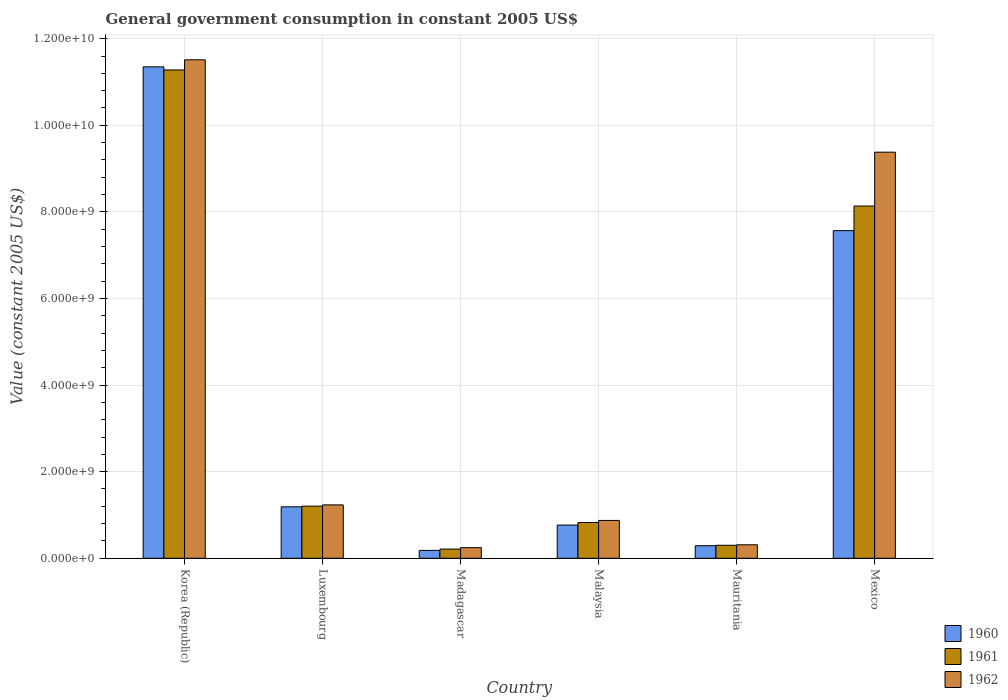How many groups of bars are there?
Your response must be concise. 6. How many bars are there on the 4th tick from the right?
Your response must be concise. 3. In how many cases, is the number of bars for a given country not equal to the number of legend labels?
Ensure brevity in your answer.  0. What is the government conusmption in 1962 in Malaysia?
Offer a terse response. 8.74e+08. Across all countries, what is the maximum government conusmption in 1961?
Give a very brief answer. 1.13e+1. Across all countries, what is the minimum government conusmption in 1961?
Provide a short and direct response. 2.12e+08. In which country was the government conusmption in 1961 maximum?
Your answer should be very brief. Korea (Republic). In which country was the government conusmption in 1962 minimum?
Your response must be concise. Madagascar. What is the total government conusmption in 1961 in the graph?
Make the answer very short. 2.20e+1. What is the difference between the government conusmption in 1961 in Malaysia and that in Mauritania?
Your answer should be compact. 5.26e+08. What is the difference between the government conusmption in 1960 in Mexico and the government conusmption in 1962 in Korea (Republic)?
Provide a succinct answer. -3.95e+09. What is the average government conusmption in 1961 per country?
Make the answer very short. 3.66e+09. What is the difference between the government conusmption of/in 1962 and government conusmption of/in 1960 in Mexico?
Give a very brief answer. 1.81e+09. What is the ratio of the government conusmption in 1960 in Korea (Republic) to that in Mauritania?
Your response must be concise. 39.21. Is the difference between the government conusmption in 1962 in Luxembourg and Mexico greater than the difference between the government conusmption in 1960 in Luxembourg and Mexico?
Offer a very short reply. No. What is the difference between the highest and the second highest government conusmption in 1961?
Offer a very short reply. -6.93e+09. What is the difference between the highest and the lowest government conusmption in 1960?
Your answer should be compact. 1.12e+1. Is the sum of the government conusmption in 1961 in Korea (Republic) and Luxembourg greater than the maximum government conusmption in 1962 across all countries?
Keep it short and to the point. Yes. Is it the case that in every country, the sum of the government conusmption in 1962 and government conusmption in 1961 is greater than the government conusmption in 1960?
Give a very brief answer. Yes. Are all the bars in the graph horizontal?
Offer a terse response. No. Are the values on the major ticks of Y-axis written in scientific E-notation?
Ensure brevity in your answer.  Yes. Does the graph contain any zero values?
Offer a terse response. No. Does the graph contain grids?
Keep it short and to the point. Yes. Where does the legend appear in the graph?
Make the answer very short. Bottom right. How many legend labels are there?
Ensure brevity in your answer.  3. How are the legend labels stacked?
Your answer should be compact. Vertical. What is the title of the graph?
Offer a terse response. General government consumption in constant 2005 US$. Does "2007" appear as one of the legend labels in the graph?
Your answer should be compact. No. What is the label or title of the X-axis?
Provide a succinct answer. Country. What is the label or title of the Y-axis?
Make the answer very short. Value (constant 2005 US$). What is the Value (constant 2005 US$) of 1960 in Korea (Republic)?
Offer a terse response. 1.13e+1. What is the Value (constant 2005 US$) of 1961 in Korea (Republic)?
Make the answer very short. 1.13e+1. What is the Value (constant 2005 US$) in 1962 in Korea (Republic)?
Your answer should be very brief. 1.15e+1. What is the Value (constant 2005 US$) in 1960 in Luxembourg?
Keep it short and to the point. 1.19e+09. What is the Value (constant 2005 US$) in 1961 in Luxembourg?
Provide a succinct answer. 1.20e+09. What is the Value (constant 2005 US$) in 1962 in Luxembourg?
Your response must be concise. 1.23e+09. What is the Value (constant 2005 US$) of 1960 in Madagascar?
Make the answer very short. 1.82e+08. What is the Value (constant 2005 US$) of 1961 in Madagascar?
Offer a terse response. 2.12e+08. What is the Value (constant 2005 US$) of 1962 in Madagascar?
Offer a terse response. 2.45e+08. What is the Value (constant 2005 US$) in 1960 in Malaysia?
Your answer should be compact. 7.67e+08. What is the Value (constant 2005 US$) of 1961 in Malaysia?
Provide a short and direct response. 8.26e+08. What is the Value (constant 2005 US$) in 1962 in Malaysia?
Your answer should be compact. 8.74e+08. What is the Value (constant 2005 US$) in 1960 in Mauritania?
Provide a succinct answer. 2.89e+08. What is the Value (constant 2005 US$) of 1961 in Mauritania?
Your answer should be very brief. 3.00e+08. What is the Value (constant 2005 US$) of 1962 in Mauritania?
Ensure brevity in your answer.  3.11e+08. What is the Value (constant 2005 US$) of 1960 in Mexico?
Make the answer very short. 7.57e+09. What is the Value (constant 2005 US$) of 1961 in Mexico?
Offer a very short reply. 8.13e+09. What is the Value (constant 2005 US$) of 1962 in Mexico?
Your response must be concise. 9.38e+09. Across all countries, what is the maximum Value (constant 2005 US$) of 1960?
Provide a succinct answer. 1.13e+1. Across all countries, what is the maximum Value (constant 2005 US$) in 1961?
Provide a succinct answer. 1.13e+1. Across all countries, what is the maximum Value (constant 2005 US$) of 1962?
Offer a very short reply. 1.15e+1. Across all countries, what is the minimum Value (constant 2005 US$) in 1960?
Offer a very short reply. 1.82e+08. Across all countries, what is the minimum Value (constant 2005 US$) in 1961?
Make the answer very short. 2.12e+08. Across all countries, what is the minimum Value (constant 2005 US$) in 1962?
Your answer should be very brief. 2.45e+08. What is the total Value (constant 2005 US$) in 1960 in the graph?
Your answer should be compact. 2.13e+1. What is the total Value (constant 2005 US$) of 1961 in the graph?
Provide a short and direct response. 2.20e+1. What is the total Value (constant 2005 US$) of 1962 in the graph?
Provide a short and direct response. 2.36e+1. What is the difference between the Value (constant 2005 US$) of 1960 in Korea (Republic) and that in Luxembourg?
Keep it short and to the point. 1.02e+1. What is the difference between the Value (constant 2005 US$) in 1961 in Korea (Republic) and that in Luxembourg?
Keep it short and to the point. 1.01e+1. What is the difference between the Value (constant 2005 US$) in 1962 in Korea (Republic) and that in Luxembourg?
Provide a short and direct response. 1.03e+1. What is the difference between the Value (constant 2005 US$) in 1960 in Korea (Republic) and that in Madagascar?
Keep it short and to the point. 1.12e+1. What is the difference between the Value (constant 2005 US$) in 1961 in Korea (Republic) and that in Madagascar?
Give a very brief answer. 1.11e+1. What is the difference between the Value (constant 2005 US$) of 1962 in Korea (Republic) and that in Madagascar?
Your answer should be compact. 1.13e+1. What is the difference between the Value (constant 2005 US$) of 1960 in Korea (Republic) and that in Malaysia?
Your answer should be compact. 1.06e+1. What is the difference between the Value (constant 2005 US$) of 1961 in Korea (Republic) and that in Malaysia?
Give a very brief answer. 1.05e+1. What is the difference between the Value (constant 2005 US$) of 1962 in Korea (Republic) and that in Malaysia?
Your response must be concise. 1.06e+1. What is the difference between the Value (constant 2005 US$) in 1960 in Korea (Republic) and that in Mauritania?
Offer a very short reply. 1.11e+1. What is the difference between the Value (constant 2005 US$) in 1961 in Korea (Republic) and that in Mauritania?
Make the answer very short. 1.10e+1. What is the difference between the Value (constant 2005 US$) of 1962 in Korea (Republic) and that in Mauritania?
Keep it short and to the point. 1.12e+1. What is the difference between the Value (constant 2005 US$) of 1960 in Korea (Republic) and that in Mexico?
Offer a very short reply. 3.78e+09. What is the difference between the Value (constant 2005 US$) of 1961 in Korea (Republic) and that in Mexico?
Give a very brief answer. 3.14e+09. What is the difference between the Value (constant 2005 US$) in 1962 in Korea (Republic) and that in Mexico?
Your answer should be compact. 2.13e+09. What is the difference between the Value (constant 2005 US$) in 1960 in Luxembourg and that in Madagascar?
Keep it short and to the point. 1.01e+09. What is the difference between the Value (constant 2005 US$) of 1961 in Luxembourg and that in Madagascar?
Give a very brief answer. 9.92e+08. What is the difference between the Value (constant 2005 US$) in 1962 in Luxembourg and that in Madagascar?
Offer a terse response. 9.87e+08. What is the difference between the Value (constant 2005 US$) in 1960 in Luxembourg and that in Malaysia?
Your response must be concise. 4.21e+08. What is the difference between the Value (constant 2005 US$) of 1961 in Luxembourg and that in Malaysia?
Provide a succinct answer. 3.77e+08. What is the difference between the Value (constant 2005 US$) of 1962 in Luxembourg and that in Malaysia?
Give a very brief answer. 3.59e+08. What is the difference between the Value (constant 2005 US$) of 1960 in Luxembourg and that in Mauritania?
Give a very brief answer. 8.99e+08. What is the difference between the Value (constant 2005 US$) of 1961 in Luxembourg and that in Mauritania?
Make the answer very short. 9.03e+08. What is the difference between the Value (constant 2005 US$) in 1962 in Luxembourg and that in Mauritania?
Make the answer very short. 9.21e+08. What is the difference between the Value (constant 2005 US$) of 1960 in Luxembourg and that in Mexico?
Your answer should be very brief. -6.38e+09. What is the difference between the Value (constant 2005 US$) of 1961 in Luxembourg and that in Mexico?
Your response must be concise. -6.93e+09. What is the difference between the Value (constant 2005 US$) of 1962 in Luxembourg and that in Mexico?
Your response must be concise. -8.15e+09. What is the difference between the Value (constant 2005 US$) of 1960 in Madagascar and that in Malaysia?
Your response must be concise. -5.85e+08. What is the difference between the Value (constant 2005 US$) in 1961 in Madagascar and that in Malaysia?
Your answer should be very brief. -6.14e+08. What is the difference between the Value (constant 2005 US$) of 1962 in Madagascar and that in Malaysia?
Make the answer very short. -6.29e+08. What is the difference between the Value (constant 2005 US$) in 1960 in Madagascar and that in Mauritania?
Your answer should be very brief. -1.08e+08. What is the difference between the Value (constant 2005 US$) of 1961 in Madagascar and that in Mauritania?
Your answer should be very brief. -8.84e+07. What is the difference between the Value (constant 2005 US$) in 1962 in Madagascar and that in Mauritania?
Provide a succinct answer. -6.62e+07. What is the difference between the Value (constant 2005 US$) in 1960 in Madagascar and that in Mexico?
Your answer should be very brief. -7.38e+09. What is the difference between the Value (constant 2005 US$) in 1961 in Madagascar and that in Mexico?
Offer a terse response. -7.92e+09. What is the difference between the Value (constant 2005 US$) in 1962 in Madagascar and that in Mexico?
Ensure brevity in your answer.  -9.13e+09. What is the difference between the Value (constant 2005 US$) of 1960 in Malaysia and that in Mauritania?
Provide a short and direct response. 4.78e+08. What is the difference between the Value (constant 2005 US$) in 1961 in Malaysia and that in Mauritania?
Provide a succinct answer. 5.26e+08. What is the difference between the Value (constant 2005 US$) in 1962 in Malaysia and that in Mauritania?
Offer a terse response. 5.63e+08. What is the difference between the Value (constant 2005 US$) of 1960 in Malaysia and that in Mexico?
Offer a very short reply. -6.80e+09. What is the difference between the Value (constant 2005 US$) of 1961 in Malaysia and that in Mexico?
Your answer should be very brief. -7.31e+09. What is the difference between the Value (constant 2005 US$) in 1962 in Malaysia and that in Mexico?
Offer a terse response. -8.50e+09. What is the difference between the Value (constant 2005 US$) in 1960 in Mauritania and that in Mexico?
Your answer should be compact. -7.28e+09. What is the difference between the Value (constant 2005 US$) in 1961 in Mauritania and that in Mexico?
Your answer should be compact. -7.83e+09. What is the difference between the Value (constant 2005 US$) in 1962 in Mauritania and that in Mexico?
Ensure brevity in your answer.  -9.07e+09. What is the difference between the Value (constant 2005 US$) of 1960 in Korea (Republic) and the Value (constant 2005 US$) of 1961 in Luxembourg?
Ensure brevity in your answer.  1.01e+1. What is the difference between the Value (constant 2005 US$) of 1960 in Korea (Republic) and the Value (constant 2005 US$) of 1962 in Luxembourg?
Your response must be concise. 1.01e+1. What is the difference between the Value (constant 2005 US$) of 1961 in Korea (Republic) and the Value (constant 2005 US$) of 1962 in Luxembourg?
Offer a very short reply. 1.00e+1. What is the difference between the Value (constant 2005 US$) in 1960 in Korea (Republic) and the Value (constant 2005 US$) in 1961 in Madagascar?
Offer a terse response. 1.11e+1. What is the difference between the Value (constant 2005 US$) in 1960 in Korea (Republic) and the Value (constant 2005 US$) in 1962 in Madagascar?
Provide a succinct answer. 1.11e+1. What is the difference between the Value (constant 2005 US$) of 1961 in Korea (Republic) and the Value (constant 2005 US$) of 1962 in Madagascar?
Provide a short and direct response. 1.10e+1. What is the difference between the Value (constant 2005 US$) in 1960 in Korea (Republic) and the Value (constant 2005 US$) in 1961 in Malaysia?
Give a very brief answer. 1.05e+1. What is the difference between the Value (constant 2005 US$) of 1960 in Korea (Republic) and the Value (constant 2005 US$) of 1962 in Malaysia?
Make the answer very short. 1.05e+1. What is the difference between the Value (constant 2005 US$) of 1961 in Korea (Republic) and the Value (constant 2005 US$) of 1962 in Malaysia?
Your response must be concise. 1.04e+1. What is the difference between the Value (constant 2005 US$) in 1960 in Korea (Republic) and the Value (constant 2005 US$) in 1961 in Mauritania?
Offer a terse response. 1.10e+1. What is the difference between the Value (constant 2005 US$) of 1960 in Korea (Republic) and the Value (constant 2005 US$) of 1962 in Mauritania?
Make the answer very short. 1.10e+1. What is the difference between the Value (constant 2005 US$) of 1961 in Korea (Republic) and the Value (constant 2005 US$) of 1962 in Mauritania?
Provide a succinct answer. 1.10e+1. What is the difference between the Value (constant 2005 US$) in 1960 in Korea (Republic) and the Value (constant 2005 US$) in 1961 in Mexico?
Provide a short and direct response. 3.21e+09. What is the difference between the Value (constant 2005 US$) in 1960 in Korea (Republic) and the Value (constant 2005 US$) in 1962 in Mexico?
Offer a very short reply. 1.97e+09. What is the difference between the Value (constant 2005 US$) of 1961 in Korea (Republic) and the Value (constant 2005 US$) of 1962 in Mexico?
Your answer should be very brief. 1.90e+09. What is the difference between the Value (constant 2005 US$) of 1960 in Luxembourg and the Value (constant 2005 US$) of 1961 in Madagascar?
Ensure brevity in your answer.  9.76e+08. What is the difference between the Value (constant 2005 US$) of 1960 in Luxembourg and the Value (constant 2005 US$) of 1962 in Madagascar?
Your response must be concise. 9.43e+08. What is the difference between the Value (constant 2005 US$) of 1961 in Luxembourg and the Value (constant 2005 US$) of 1962 in Madagascar?
Provide a succinct answer. 9.59e+08. What is the difference between the Value (constant 2005 US$) of 1960 in Luxembourg and the Value (constant 2005 US$) of 1961 in Malaysia?
Provide a succinct answer. 3.62e+08. What is the difference between the Value (constant 2005 US$) of 1960 in Luxembourg and the Value (constant 2005 US$) of 1962 in Malaysia?
Your answer should be compact. 3.14e+08. What is the difference between the Value (constant 2005 US$) in 1961 in Luxembourg and the Value (constant 2005 US$) in 1962 in Malaysia?
Your answer should be compact. 3.30e+08. What is the difference between the Value (constant 2005 US$) of 1960 in Luxembourg and the Value (constant 2005 US$) of 1961 in Mauritania?
Offer a terse response. 8.88e+08. What is the difference between the Value (constant 2005 US$) in 1960 in Luxembourg and the Value (constant 2005 US$) in 1962 in Mauritania?
Your answer should be compact. 8.77e+08. What is the difference between the Value (constant 2005 US$) in 1961 in Luxembourg and the Value (constant 2005 US$) in 1962 in Mauritania?
Offer a terse response. 8.92e+08. What is the difference between the Value (constant 2005 US$) of 1960 in Luxembourg and the Value (constant 2005 US$) of 1961 in Mexico?
Offer a very short reply. -6.95e+09. What is the difference between the Value (constant 2005 US$) of 1960 in Luxembourg and the Value (constant 2005 US$) of 1962 in Mexico?
Offer a terse response. -8.19e+09. What is the difference between the Value (constant 2005 US$) in 1961 in Luxembourg and the Value (constant 2005 US$) in 1962 in Mexico?
Keep it short and to the point. -8.18e+09. What is the difference between the Value (constant 2005 US$) in 1960 in Madagascar and the Value (constant 2005 US$) in 1961 in Malaysia?
Provide a succinct answer. -6.45e+08. What is the difference between the Value (constant 2005 US$) in 1960 in Madagascar and the Value (constant 2005 US$) in 1962 in Malaysia?
Give a very brief answer. -6.92e+08. What is the difference between the Value (constant 2005 US$) in 1961 in Madagascar and the Value (constant 2005 US$) in 1962 in Malaysia?
Your answer should be compact. -6.62e+08. What is the difference between the Value (constant 2005 US$) of 1960 in Madagascar and the Value (constant 2005 US$) of 1961 in Mauritania?
Give a very brief answer. -1.19e+08. What is the difference between the Value (constant 2005 US$) in 1960 in Madagascar and the Value (constant 2005 US$) in 1962 in Mauritania?
Your response must be concise. -1.30e+08. What is the difference between the Value (constant 2005 US$) in 1961 in Madagascar and the Value (constant 2005 US$) in 1962 in Mauritania?
Your response must be concise. -9.93e+07. What is the difference between the Value (constant 2005 US$) in 1960 in Madagascar and the Value (constant 2005 US$) in 1961 in Mexico?
Provide a short and direct response. -7.95e+09. What is the difference between the Value (constant 2005 US$) of 1960 in Madagascar and the Value (constant 2005 US$) of 1962 in Mexico?
Ensure brevity in your answer.  -9.20e+09. What is the difference between the Value (constant 2005 US$) in 1961 in Madagascar and the Value (constant 2005 US$) in 1962 in Mexico?
Ensure brevity in your answer.  -9.17e+09. What is the difference between the Value (constant 2005 US$) of 1960 in Malaysia and the Value (constant 2005 US$) of 1961 in Mauritania?
Make the answer very short. 4.67e+08. What is the difference between the Value (constant 2005 US$) of 1960 in Malaysia and the Value (constant 2005 US$) of 1962 in Mauritania?
Your response must be concise. 4.56e+08. What is the difference between the Value (constant 2005 US$) of 1961 in Malaysia and the Value (constant 2005 US$) of 1962 in Mauritania?
Keep it short and to the point. 5.15e+08. What is the difference between the Value (constant 2005 US$) of 1960 in Malaysia and the Value (constant 2005 US$) of 1961 in Mexico?
Your response must be concise. -7.37e+09. What is the difference between the Value (constant 2005 US$) in 1960 in Malaysia and the Value (constant 2005 US$) in 1962 in Mexico?
Provide a short and direct response. -8.61e+09. What is the difference between the Value (constant 2005 US$) of 1961 in Malaysia and the Value (constant 2005 US$) of 1962 in Mexico?
Make the answer very short. -8.55e+09. What is the difference between the Value (constant 2005 US$) of 1960 in Mauritania and the Value (constant 2005 US$) of 1961 in Mexico?
Keep it short and to the point. -7.85e+09. What is the difference between the Value (constant 2005 US$) of 1960 in Mauritania and the Value (constant 2005 US$) of 1962 in Mexico?
Make the answer very short. -9.09e+09. What is the difference between the Value (constant 2005 US$) in 1961 in Mauritania and the Value (constant 2005 US$) in 1962 in Mexico?
Provide a short and direct response. -9.08e+09. What is the average Value (constant 2005 US$) in 1960 per country?
Your answer should be very brief. 3.56e+09. What is the average Value (constant 2005 US$) of 1961 per country?
Give a very brief answer. 3.66e+09. What is the average Value (constant 2005 US$) of 1962 per country?
Offer a terse response. 3.93e+09. What is the difference between the Value (constant 2005 US$) of 1960 and Value (constant 2005 US$) of 1961 in Korea (Republic)?
Offer a terse response. 7.08e+07. What is the difference between the Value (constant 2005 US$) of 1960 and Value (constant 2005 US$) of 1962 in Korea (Republic)?
Your answer should be compact. -1.63e+08. What is the difference between the Value (constant 2005 US$) in 1961 and Value (constant 2005 US$) in 1962 in Korea (Republic)?
Your response must be concise. -2.34e+08. What is the difference between the Value (constant 2005 US$) in 1960 and Value (constant 2005 US$) in 1961 in Luxembourg?
Make the answer very short. -1.55e+07. What is the difference between the Value (constant 2005 US$) of 1960 and Value (constant 2005 US$) of 1962 in Luxembourg?
Provide a succinct answer. -4.43e+07. What is the difference between the Value (constant 2005 US$) in 1961 and Value (constant 2005 US$) in 1962 in Luxembourg?
Offer a terse response. -2.88e+07. What is the difference between the Value (constant 2005 US$) in 1960 and Value (constant 2005 US$) in 1961 in Madagascar?
Your answer should be compact. -3.02e+07. What is the difference between the Value (constant 2005 US$) in 1960 and Value (constant 2005 US$) in 1962 in Madagascar?
Give a very brief answer. -6.34e+07. What is the difference between the Value (constant 2005 US$) in 1961 and Value (constant 2005 US$) in 1962 in Madagascar?
Offer a terse response. -3.32e+07. What is the difference between the Value (constant 2005 US$) in 1960 and Value (constant 2005 US$) in 1961 in Malaysia?
Keep it short and to the point. -5.92e+07. What is the difference between the Value (constant 2005 US$) of 1960 and Value (constant 2005 US$) of 1962 in Malaysia?
Offer a terse response. -1.07e+08. What is the difference between the Value (constant 2005 US$) of 1961 and Value (constant 2005 US$) of 1962 in Malaysia?
Provide a succinct answer. -4.75e+07. What is the difference between the Value (constant 2005 US$) in 1960 and Value (constant 2005 US$) in 1961 in Mauritania?
Your answer should be very brief. -1.09e+07. What is the difference between the Value (constant 2005 US$) in 1960 and Value (constant 2005 US$) in 1962 in Mauritania?
Make the answer very short. -2.18e+07. What is the difference between the Value (constant 2005 US$) of 1961 and Value (constant 2005 US$) of 1962 in Mauritania?
Give a very brief answer. -1.09e+07. What is the difference between the Value (constant 2005 US$) of 1960 and Value (constant 2005 US$) of 1961 in Mexico?
Offer a terse response. -5.68e+08. What is the difference between the Value (constant 2005 US$) in 1960 and Value (constant 2005 US$) in 1962 in Mexico?
Your response must be concise. -1.81e+09. What is the difference between the Value (constant 2005 US$) in 1961 and Value (constant 2005 US$) in 1962 in Mexico?
Your answer should be compact. -1.24e+09. What is the ratio of the Value (constant 2005 US$) in 1960 in Korea (Republic) to that in Luxembourg?
Keep it short and to the point. 9.55. What is the ratio of the Value (constant 2005 US$) of 1961 in Korea (Republic) to that in Luxembourg?
Your response must be concise. 9.37. What is the ratio of the Value (constant 2005 US$) in 1962 in Korea (Republic) to that in Luxembourg?
Keep it short and to the point. 9.34. What is the ratio of the Value (constant 2005 US$) in 1960 in Korea (Republic) to that in Madagascar?
Give a very brief answer. 62.43. What is the ratio of the Value (constant 2005 US$) of 1961 in Korea (Republic) to that in Madagascar?
Make the answer very short. 53.2. What is the ratio of the Value (constant 2005 US$) in 1962 in Korea (Republic) to that in Madagascar?
Ensure brevity in your answer.  46.96. What is the ratio of the Value (constant 2005 US$) in 1960 in Korea (Republic) to that in Malaysia?
Give a very brief answer. 14.79. What is the ratio of the Value (constant 2005 US$) in 1961 in Korea (Republic) to that in Malaysia?
Your answer should be very brief. 13.65. What is the ratio of the Value (constant 2005 US$) in 1962 in Korea (Republic) to that in Malaysia?
Your response must be concise. 13.17. What is the ratio of the Value (constant 2005 US$) of 1960 in Korea (Republic) to that in Mauritania?
Offer a terse response. 39.21. What is the ratio of the Value (constant 2005 US$) in 1961 in Korea (Republic) to that in Mauritania?
Your response must be concise. 37.55. What is the ratio of the Value (constant 2005 US$) in 1962 in Korea (Republic) to that in Mauritania?
Offer a very short reply. 36.98. What is the ratio of the Value (constant 2005 US$) in 1960 in Korea (Republic) to that in Mexico?
Offer a terse response. 1.5. What is the ratio of the Value (constant 2005 US$) in 1961 in Korea (Republic) to that in Mexico?
Your answer should be very brief. 1.39. What is the ratio of the Value (constant 2005 US$) in 1962 in Korea (Republic) to that in Mexico?
Ensure brevity in your answer.  1.23. What is the ratio of the Value (constant 2005 US$) of 1960 in Luxembourg to that in Madagascar?
Offer a terse response. 6.54. What is the ratio of the Value (constant 2005 US$) of 1961 in Luxembourg to that in Madagascar?
Make the answer very short. 5.68. What is the ratio of the Value (constant 2005 US$) of 1962 in Luxembourg to that in Madagascar?
Make the answer very short. 5.03. What is the ratio of the Value (constant 2005 US$) of 1960 in Luxembourg to that in Malaysia?
Provide a succinct answer. 1.55. What is the ratio of the Value (constant 2005 US$) in 1961 in Luxembourg to that in Malaysia?
Make the answer very short. 1.46. What is the ratio of the Value (constant 2005 US$) in 1962 in Luxembourg to that in Malaysia?
Your response must be concise. 1.41. What is the ratio of the Value (constant 2005 US$) in 1960 in Luxembourg to that in Mauritania?
Your answer should be very brief. 4.11. What is the ratio of the Value (constant 2005 US$) of 1961 in Luxembourg to that in Mauritania?
Your answer should be compact. 4.01. What is the ratio of the Value (constant 2005 US$) in 1962 in Luxembourg to that in Mauritania?
Provide a short and direct response. 3.96. What is the ratio of the Value (constant 2005 US$) of 1960 in Luxembourg to that in Mexico?
Provide a succinct answer. 0.16. What is the ratio of the Value (constant 2005 US$) in 1961 in Luxembourg to that in Mexico?
Keep it short and to the point. 0.15. What is the ratio of the Value (constant 2005 US$) of 1962 in Luxembourg to that in Mexico?
Your answer should be very brief. 0.13. What is the ratio of the Value (constant 2005 US$) of 1960 in Madagascar to that in Malaysia?
Ensure brevity in your answer.  0.24. What is the ratio of the Value (constant 2005 US$) in 1961 in Madagascar to that in Malaysia?
Your answer should be very brief. 0.26. What is the ratio of the Value (constant 2005 US$) in 1962 in Madagascar to that in Malaysia?
Make the answer very short. 0.28. What is the ratio of the Value (constant 2005 US$) in 1960 in Madagascar to that in Mauritania?
Your response must be concise. 0.63. What is the ratio of the Value (constant 2005 US$) of 1961 in Madagascar to that in Mauritania?
Offer a very short reply. 0.71. What is the ratio of the Value (constant 2005 US$) of 1962 in Madagascar to that in Mauritania?
Ensure brevity in your answer.  0.79. What is the ratio of the Value (constant 2005 US$) of 1960 in Madagascar to that in Mexico?
Give a very brief answer. 0.02. What is the ratio of the Value (constant 2005 US$) in 1961 in Madagascar to that in Mexico?
Give a very brief answer. 0.03. What is the ratio of the Value (constant 2005 US$) in 1962 in Madagascar to that in Mexico?
Ensure brevity in your answer.  0.03. What is the ratio of the Value (constant 2005 US$) of 1960 in Malaysia to that in Mauritania?
Ensure brevity in your answer.  2.65. What is the ratio of the Value (constant 2005 US$) in 1961 in Malaysia to that in Mauritania?
Your answer should be compact. 2.75. What is the ratio of the Value (constant 2005 US$) of 1962 in Malaysia to that in Mauritania?
Keep it short and to the point. 2.81. What is the ratio of the Value (constant 2005 US$) of 1960 in Malaysia to that in Mexico?
Ensure brevity in your answer.  0.1. What is the ratio of the Value (constant 2005 US$) of 1961 in Malaysia to that in Mexico?
Keep it short and to the point. 0.1. What is the ratio of the Value (constant 2005 US$) in 1962 in Malaysia to that in Mexico?
Give a very brief answer. 0.09. What is the ratio of the Value (constant 2005 US$) of 1960 in Mauritania to that in Mexico?
Your response must be concise. 0.04. What is the ratio of the Value (constant 2005 US$) of 1961 in Mauritania to that in Mexico?
Your answer should be very brief. 0.04. What is the ratio of the Value (constant 2005 US$) of 1962 in Mauritania to that in Mexico?
Your response must be concise. 0.03. What is the difference between the highest and the second highest Value (constant 2005 US$) of 1960?
Provide a short and direct response. 3.78e+09. What is the difference between the highest and the second highest Value (constant 2005 US$) in 1961?
Offer a very short reply. 3.14e+09. What is the difference between the highest and the second highest Value (constant 2005 US$) of 1962?
Provide a short and direct response. 2.13e+09. What is the difference between the highest and the lowest Value (constant 2005 US$) in 1960?
Your answer should be very brief. 1.12e+1. What is the difference between the highest and the lowest Value (constant 2005 US$) in 1961?
Offer a very short reply. 1.11e+1. What is the difference between the highest and the lowest Value (constant 2005 US$) of 1962?
Provide a short and direct response. 1.13e+1. 